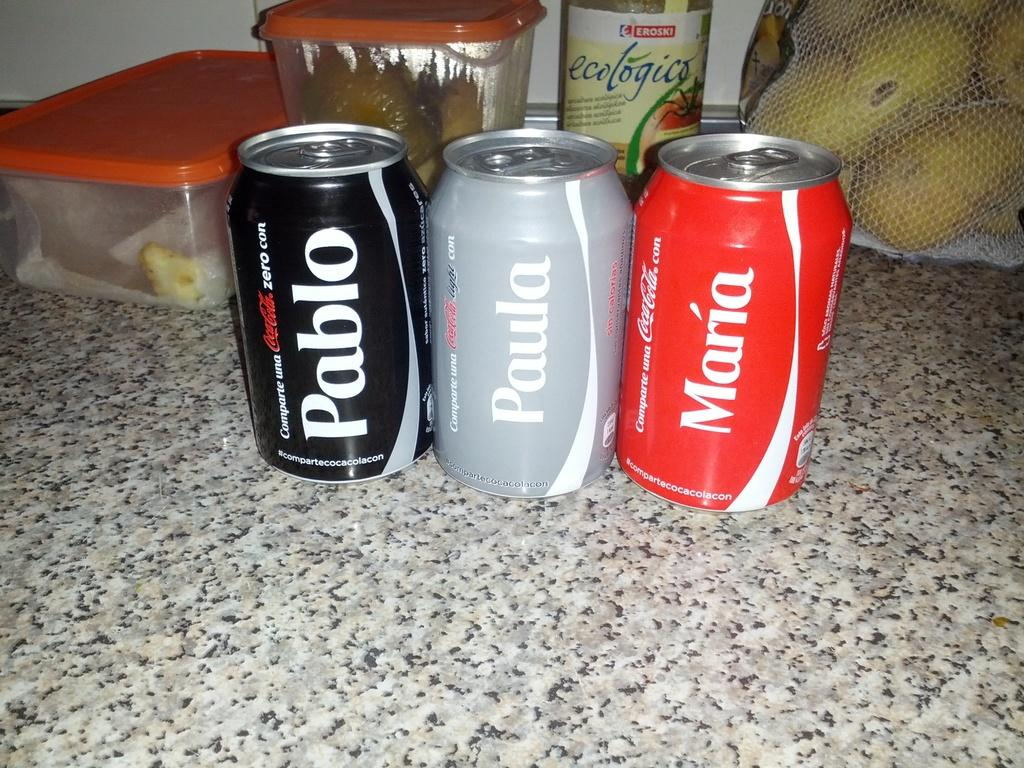<image>
Write a terse but informative summary of the picture. A row of soda cans that say Pablo, Paula, and Maria are on a granite counter. 